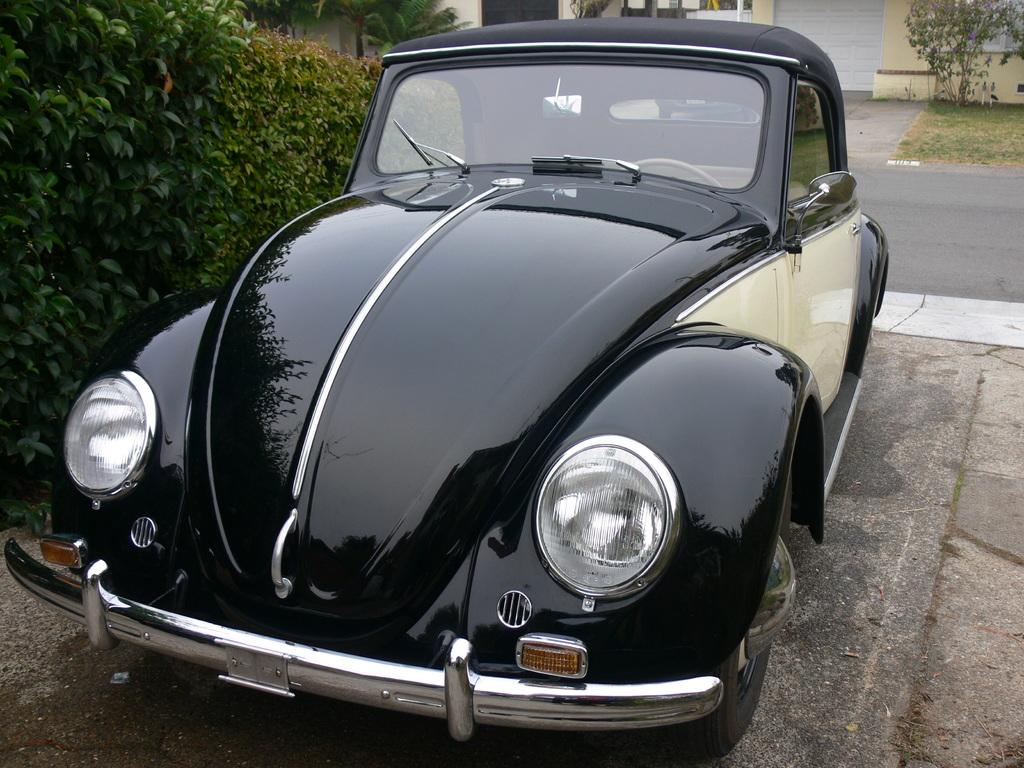What color is the car in the image? The car in the image is black. Where is the car located in the image? The car is on the ground. What can be seen on the left side of the image? There are plants on the left side of the image. What is visible in the background of the image? There is a road, a shutter, a wall, grass, and a tree in the background of the image. What historical event is being commemorated by the crime scene in the image? There is no crime scene or historical event present in the image; it features a black car on the ground with plants on the left side and various background elements. 